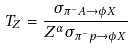<formula> <loc_0><loc_0><loc_500><loc_500>T _ { Z } = \frac { \sigma _ { \pi ^ { - } A \rightarrow \phi X } } { Z ^ { \alpha } \sigma _ { \pi ^ { - } p \rightarrow \phi X } }</formula> 